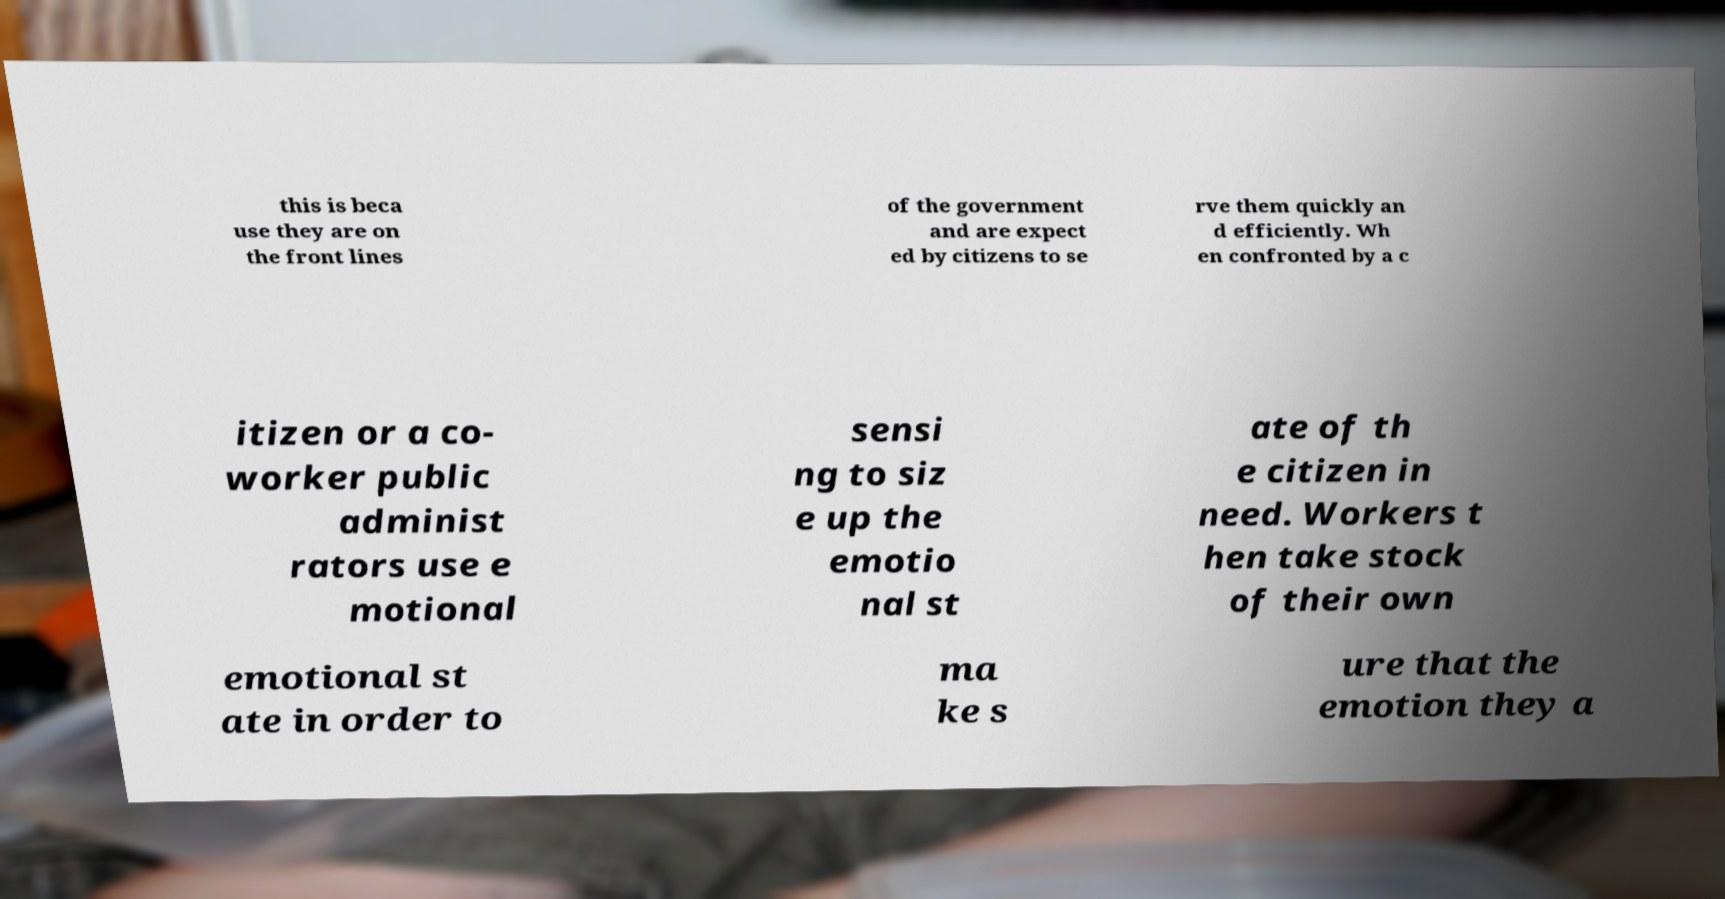Could you assist in decoding the text presented in this image and type it out clearly? this is beca use they are on the front lines of the government and are expect ed by citizens to se rve them quickly an d efficiently. Wh en confronted by a c itizen or a co- worker public administ rators use e motional sensi ng to siz e up the emotio nal st ate of th e citizen in need. Workers t hen take stock of their own emotional st ate in order to ma ke s ure that the emotion they a 